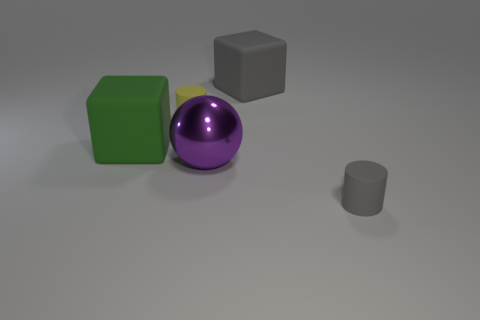What is the size of the matte cylinder behind the gray rubber thing that is in front of the gray cube?
Give a very brief answer. Small. What material is the large object that is on the right side of the green object and in front of the small yellow matte cylinder?
Offer a terse response. Metal. There is a purple object; is its size the same as the cylinder that is behind the green rubber object?
Provide a short and direct response. No. Are any big green rubber balls visible?
Your answer should be very brief. No. There is a small gray object that is the same shape as the yellow object; what is its material?
Your response must be concise. Rubber. There is a gray matte thing that is behind the gray matte object that is in front of the big cube that is on the right side of the large green rubber thing; what is its size?
Ensure brevity in your answer.  Large. Are there any tiny cylinders on the right side of the metal object?
Offer a very short reply. Yes. There is a gray block that is made of the same material as the green thing; what is its size?
Ensure brevity in your answer.  Large. How many tiny gray objects have the same shape as the big gray matte thing?
Provide a short and direct response. 0. Does the large purple object have the same material as the tiny cylinder on the right side of the large purple metal ball?
Ensure brevity in your answer.  No. 